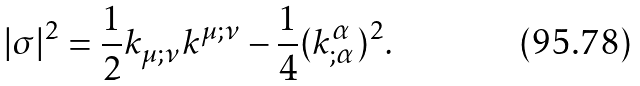Convert formula to latex. <formula><loc_0><loc_0><loc_500><loc_500>| \sigma | ^ { 2 } = \frac { 1 } { 2 } k _ { \mu ; \nu } k ^ { \mu ; \nu } - \frac { 1 } { 4 } ( k ^ { \alpha } _ { ; \alpha } ) ^ { 2 } .</formula> 